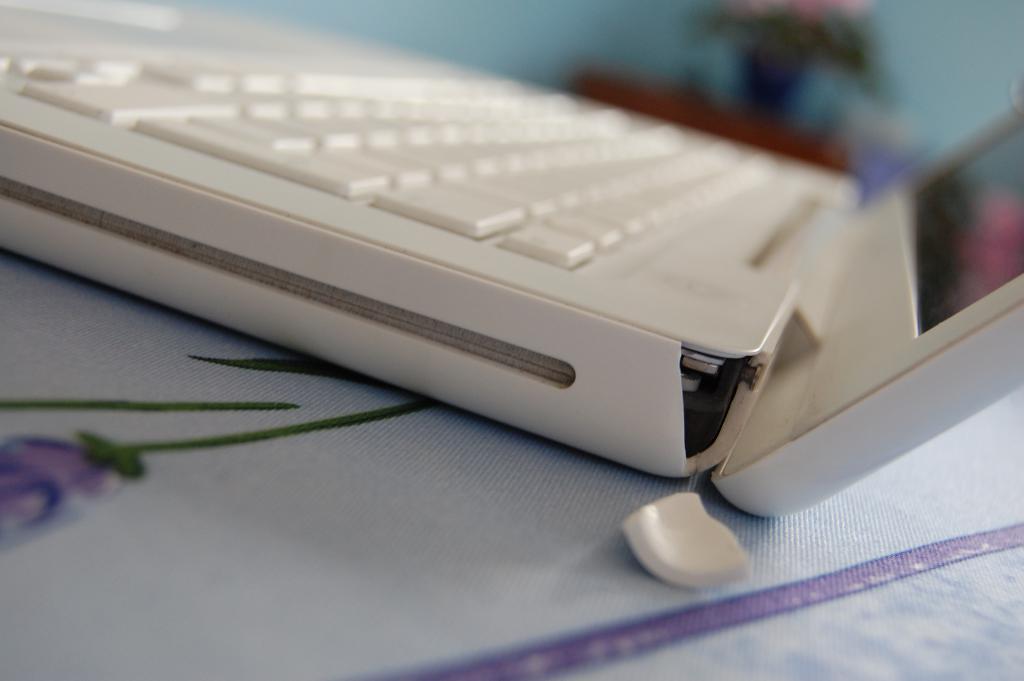Can you describe this image briefly? In this image there is laptop in the center and the background is blurry. 